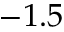<formula> <loc_0><loc_0><loc_500><loc_500>- 1 . 5</formula> 